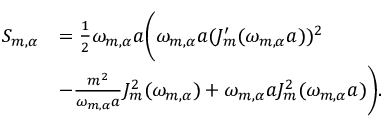Convert formula to latex. <formula><loc_0><loc_0><loc_500><loc_500>\begin{array} { r l } { S _ { m , \alpha } } & { = \frac { 1 } { 2 } \omega _ { m , \alpha } a \left ( \omega _ { m , \alpha } a ( J _ { m } ^ { \prime } ( \omega _ { m , \alpha } a ) ) ^ { 2 } } \\ & { - \frac { m ^ { 2 } } { \omega _ { m , \alpha } a } J _ { m } ^ { 2 } ( \omega _ { m , \alpha } ) + \omega _ { m , \alpha } a J _ { m } ^ { 2 } ( \omega _ { m , \alpha } a ) \right ) . } \end{array}</formula> 